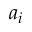<formula> <loc_0><loc_0><loc_500><loc_500>a _ { i }</formula> 